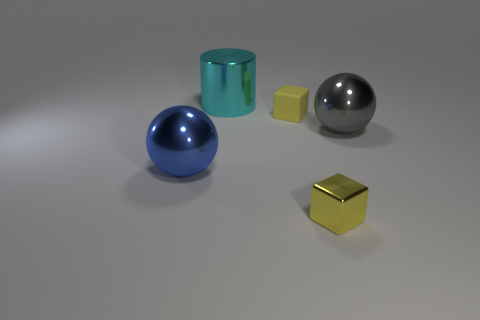Is the color of the small thing that is on the left side of the small shiny cube the same as the tiny shiny thing?
Your answer should be compact. Yes. How many other things are made of the same material as the cyan cylinder?
Give a very brief answer. 3. What is the size of the blue metallic ball?
Ensure brevity in your answer.  Large. How many other things are the same color as the metal cylinder?
Your answer should be very brief. 0. The large shiny object that is both left of the yellow metal cube and behind the blue ball is what color?
Offer a terse response. Cyan. How many small purple metallic cylinders are there?
Provide a short and direct response. 0. Do the large blue object and the big cylinder have the same material?
Your response must be concise. Yes. The big metallic thing behind the sphere behind the sphere on the left side of the large cylinder is what shape?
Your response must be concise. Cylinder. Does the yellow cube that is in front of the tiny yellow matte object have the same material as the cube behind the big blue sphere?
Offer a terse response. No. What material is the cyan object?
Your answer should be compact. Metal. 